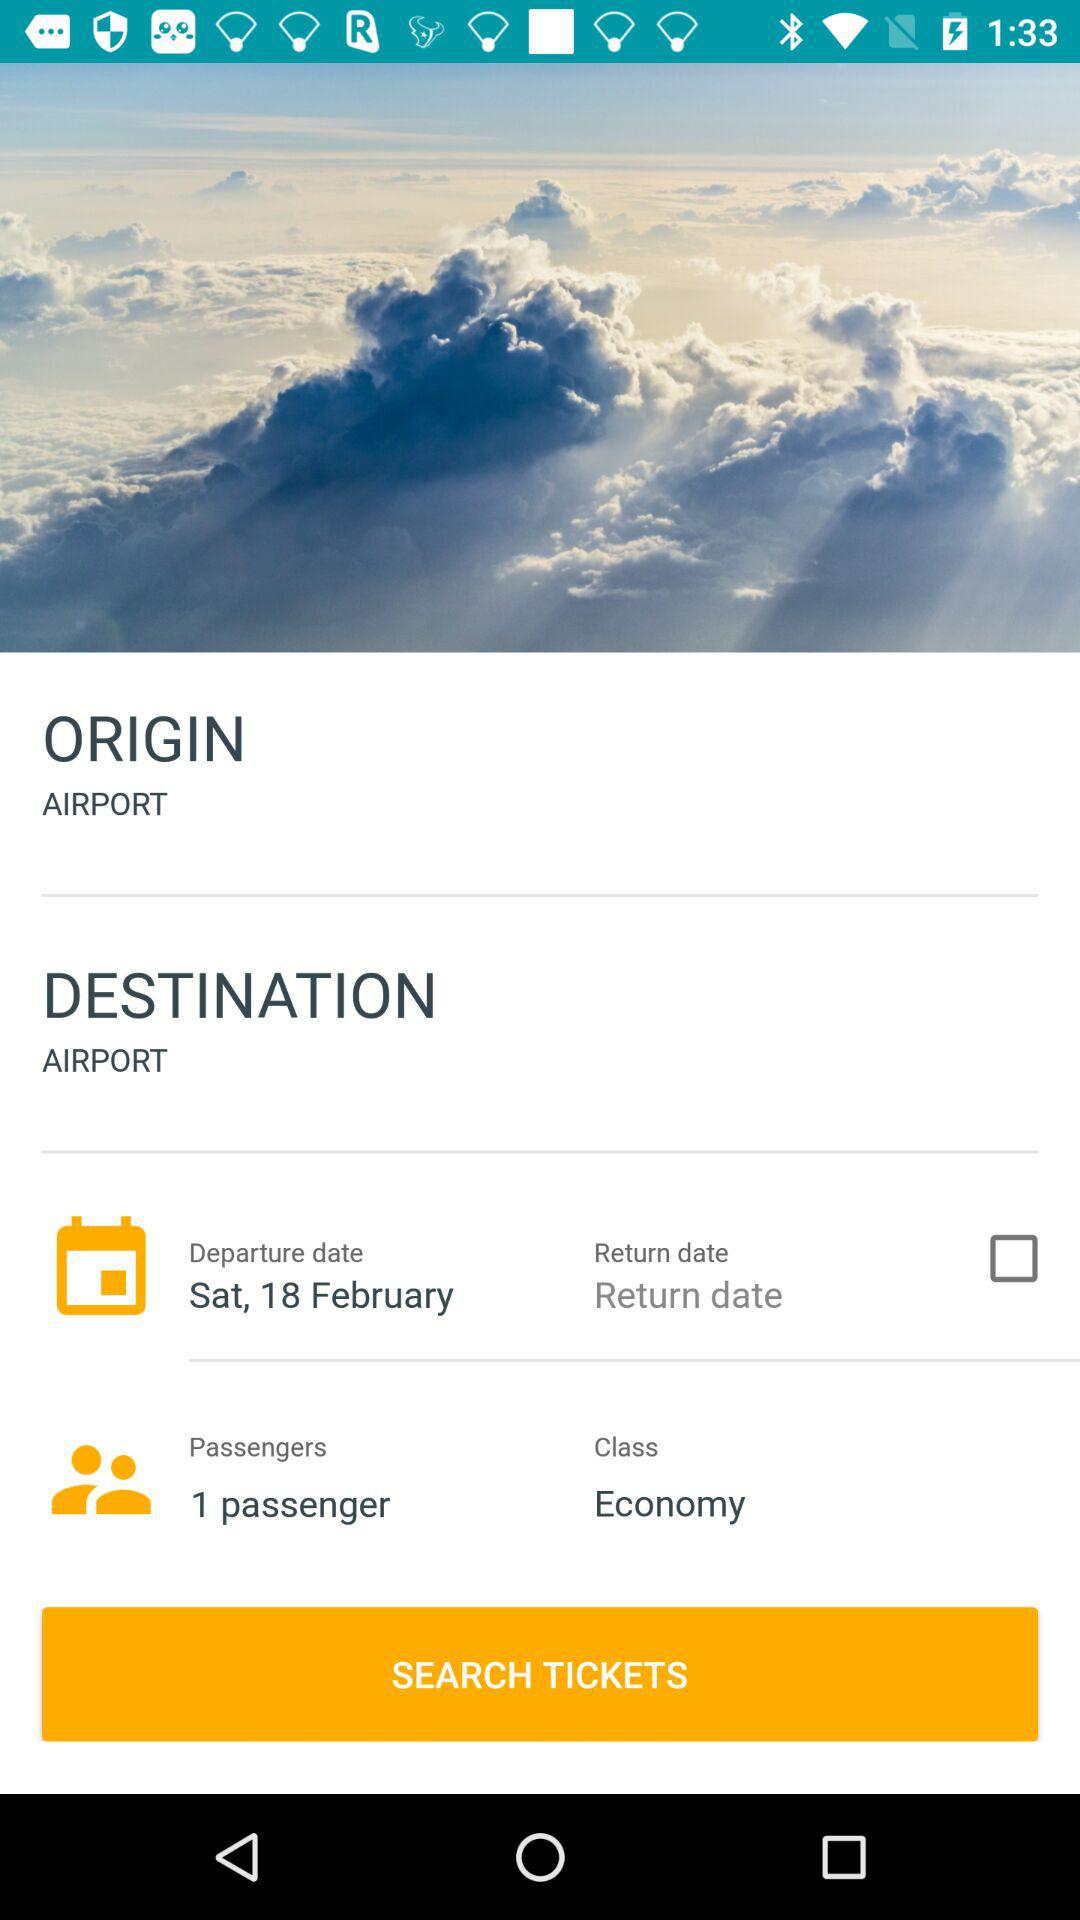What is the origin of this trip? The origin is "AIRPORT". 